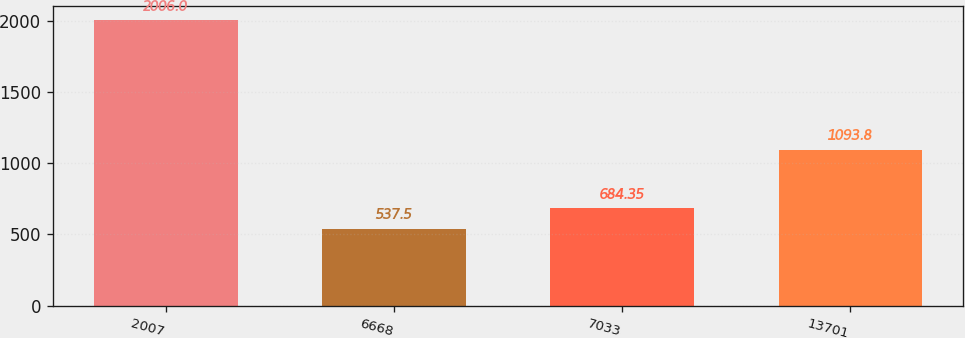Convert chart. <chart><loc_0><loc_0><loc_500><loc_500><bar_chart><fcel>2007<fcel>6668<fcel>7033<fcel>13701<nl><fcel>2006<fcel>537.5<fcel>684.35<fcel>1093.8<nl></chart> 